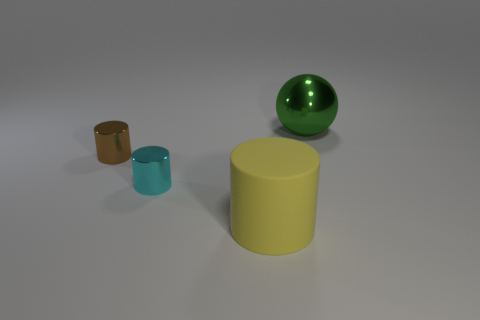What number of other objects are there of the same material as the small brown object?
Your answer should be very brief. 2. What size is the metallic sphere?
Offer a very short reply. Large. Are there any yellow matte things of the same shape as the big metallic thing?
Keep it short and to the point. No. What number of things are gray balls or big things that are in front of the large green shiny thing?
Your answer should be compact. 1. What color is the small metal cylinder in front of the tiny brown metallic cylinder?
Your response must be concise. Cyan. Is the size of the shiny thing on the right side of the big yellow matte cylinder the same as the metallic object in front of the tiny brown shiny cylinder?
Your response must be concise. No. Is there a purple metallic cylinder of the same size as the green metallic object?
Provide a short and direct response. No. There is a big thing that is in front of the large green shiny thing; how many cyan things are right of it?
Keep it short and to the point. 0. What is the material of the green object?
Your answer should be very brief. Metal. There is a brown thing; what number of big matte cylinders are to the right of it?
Offer a very short reply. 1. 